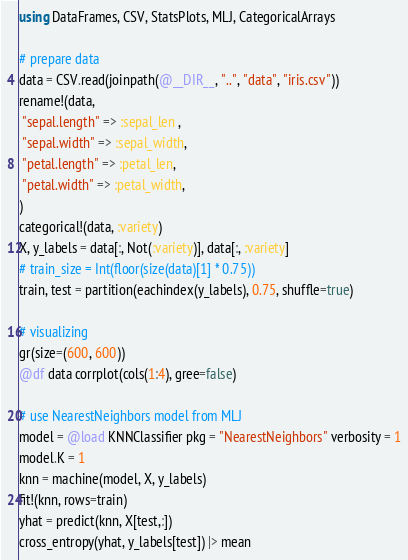<code> <loc_0><loc_0><loc_500><loc_500><_Julia_>using DataFrames, CSV, StatsPlots, MLJ, CategoricalArrays

# prepare data
data = CSV.read(joinpath(@__DIR__, "..", "data", "iris.csv"))
rename!(data, 
 "sepal.length" => :sepal_len ,
 "sepal.width" => :sepal_width,
 "petal.length" => :petal_len,
 "petal.width" => :petal_width,
)
categorical!(data, :variety)
X, y_labels = data[:, Not(:variety)], data[:, :variety]
# train_size = Int(floor(size(data)[1] * 0.75))
train, test = partition(eachindex(y_labels), 0.75, shuffle=true)

# visualizing
gr(size=(600, 600))
@df data corrplot(cols(1:4), gree=false)

# use NearestNeighbors model from MLJ
model = @load KNNClassifier pkg = "NearestNeighbors" verbosity = 1
model.K = 1
knn = machine(model, X, y_labels)
fit!(knn, rows=train)
yhat = predict(knn, X[test,:])
cross_entropy(yhat, y_labels[test]) |> mean</code> 